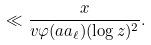<formula> <loc_0><loc_0><loc_500><loc_500>\ll \frac { x } { v \varphi ( a a _ { \ell } ) ( \log z ) ^ { 2 } } .</formula> 